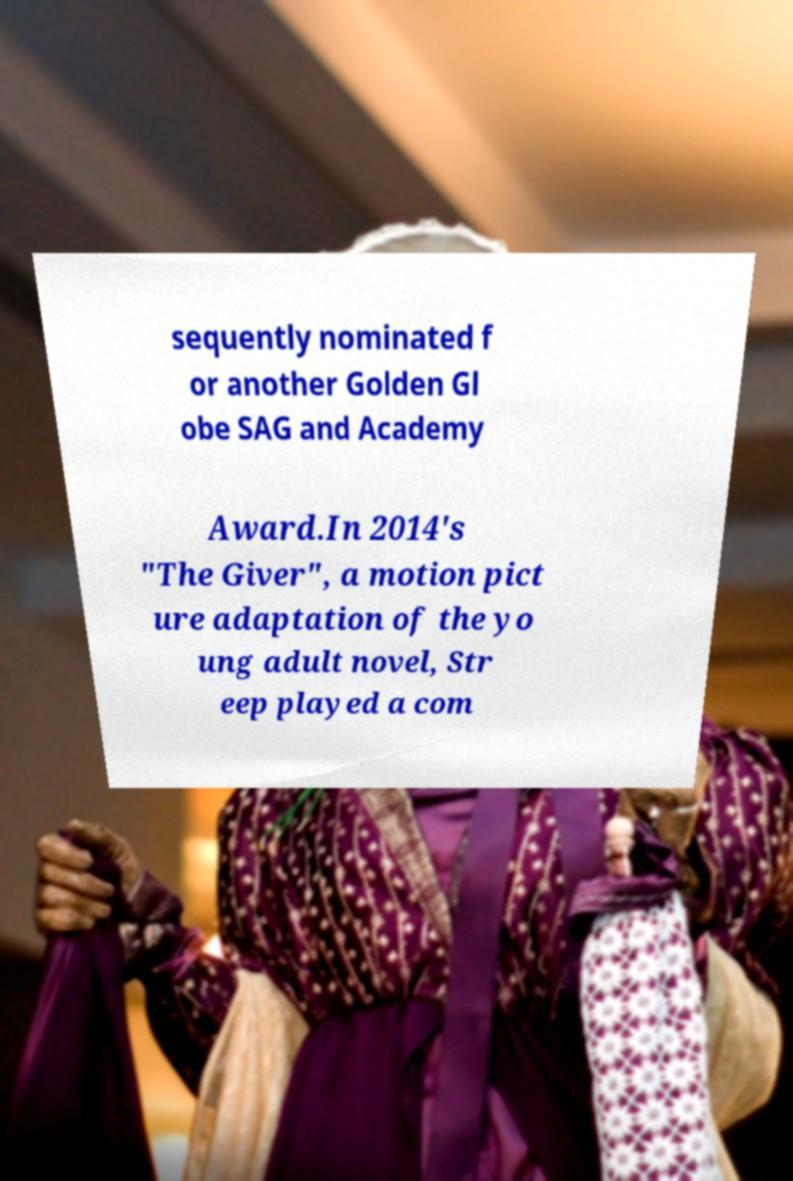Can you read and provide the text displayed in the image?This photo seems to have some interesting text. Can you extract and type it out for me? sequently nominated f or another Golden Gl obe SAG and Academy Award.In 2014's "The Giver", a motion pict ure adaptation of the yo ung adult novel, Str eep played a com 